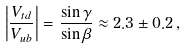Convert formula to latex. <formula><loc_0><loc_0><loc_500><loc_500>\left | \frac { V _ { t d } } { V _ { u b } } \right | = \frac { \sin \gamma } { \sin \beta } \approx 2 . 3 \pm 0 . 2 \, ,</formula> 